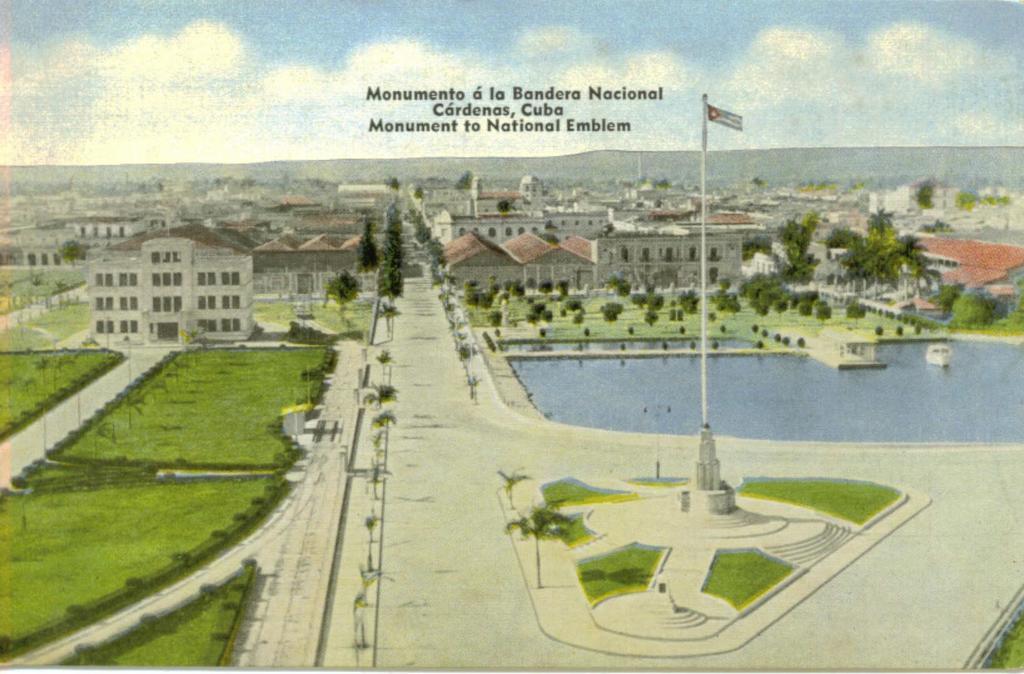Can you describe this image briefly? In this image we can see a poster with text and image of few buildings, trees, grass, flag, mountains and the sky in the background. 